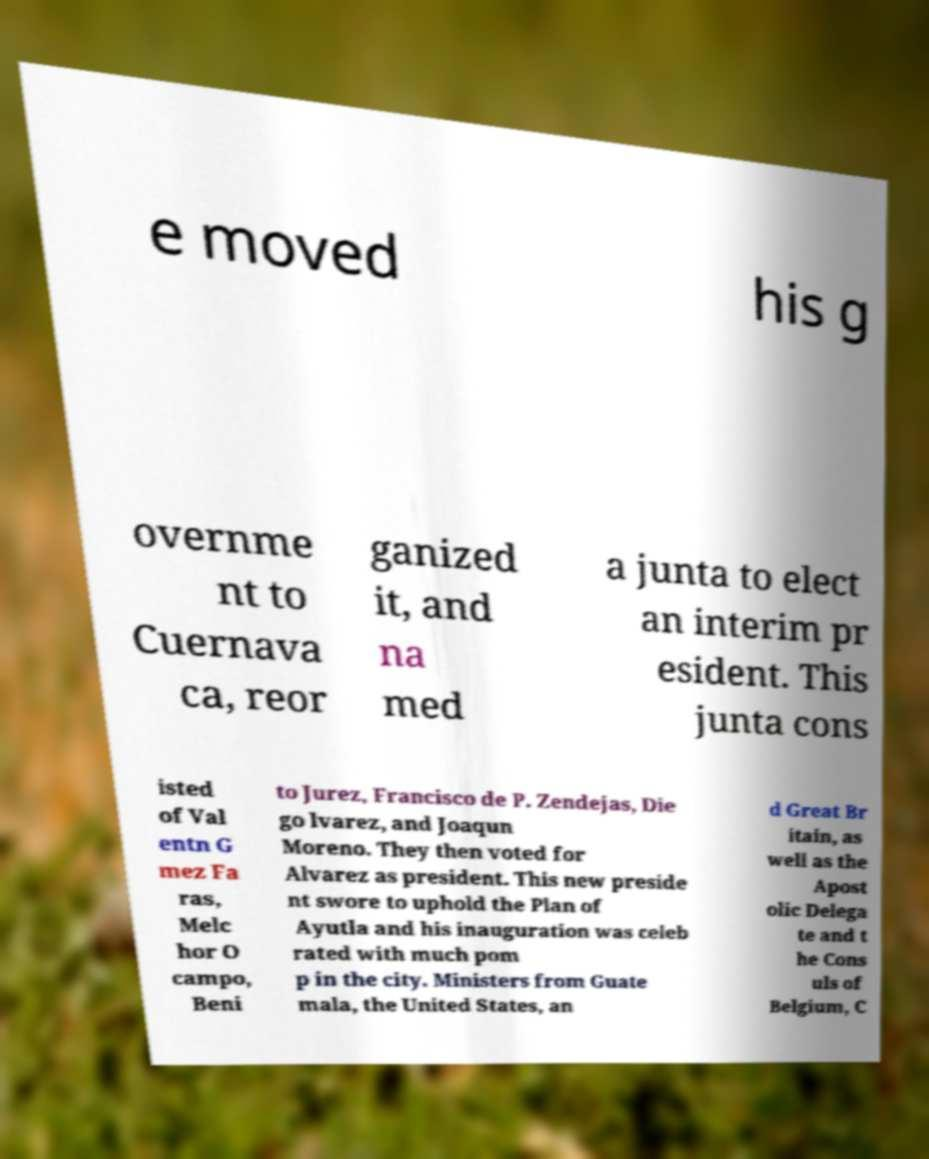Please identify and transcribe the text found in this image. e moved his g overnme nt to Cuernava ca, reor ganized it, and na med a junta to elect an interim pr esident. This junta cons isted of Val entn G mez Fa ras, Melc hor O campo, Beni to Jurez, Francisco de P. Zendejas, Die go lvarez, and Joaqun Moreno. They then voted for Alvarez as president. This new preside nt swore to uphold the Plan of Ayutla and his inauguration was celeb rated with much pom p in the city. Ministers from Guate mala, the United States, an d Great Br itain, as well as the Apost olic Delega te and t he Cons uls of Belgium, C 